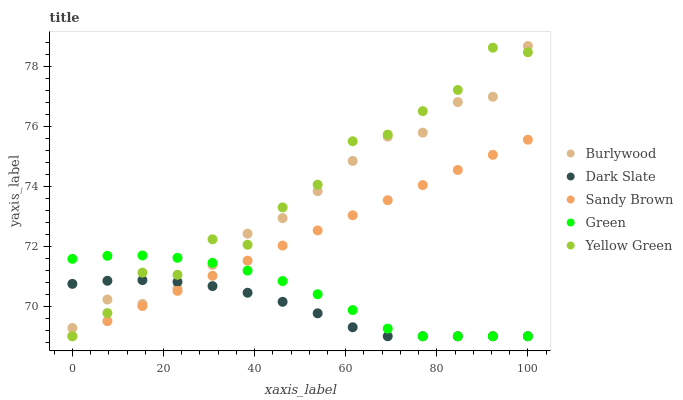Does Dark Slate have the minimum area under the curve?
Answer yes or no. Yes. Does Yellow Green have the maximum area under the curve?
Answer yes or no. Yes. Does Green have the minimum area under the curve?
Answer yes or no. No. Does Green have the maximum area under the curve?
Answer yes or no. No. Is Sandy Brown the smoothest?
Answer yes or no. Yes. Is Yellow Green the roughest?
Answer yes or no. Yes. Is Dark Slate the smoothest?
Answer yes or no. No. Is Dark Slate the roughest?
Answer yes or no. No. Does Dark Slate have the lowest value?
Answer yes or no. Yes. Does Burlywood have the highest value?
Answer yes or no. Yes. Does Green have the highest value?
Answer yes or no. No. Is Sandy Brown less than Burlywood?
Answer yes or no. Yes. Is Burlywood greater than Sandy Brown?
Answer yes or no. Yes. Does Green intersect Sandy Brown?
Answer yes or no. Yes. Is Green less than Sandy Brown?
Answer yes or no. No. Is Green greater than Sandy Brown?
Answer yes or no. No. Does Sandy Brown intersect Burlywood?
Answer yes or no. No. 